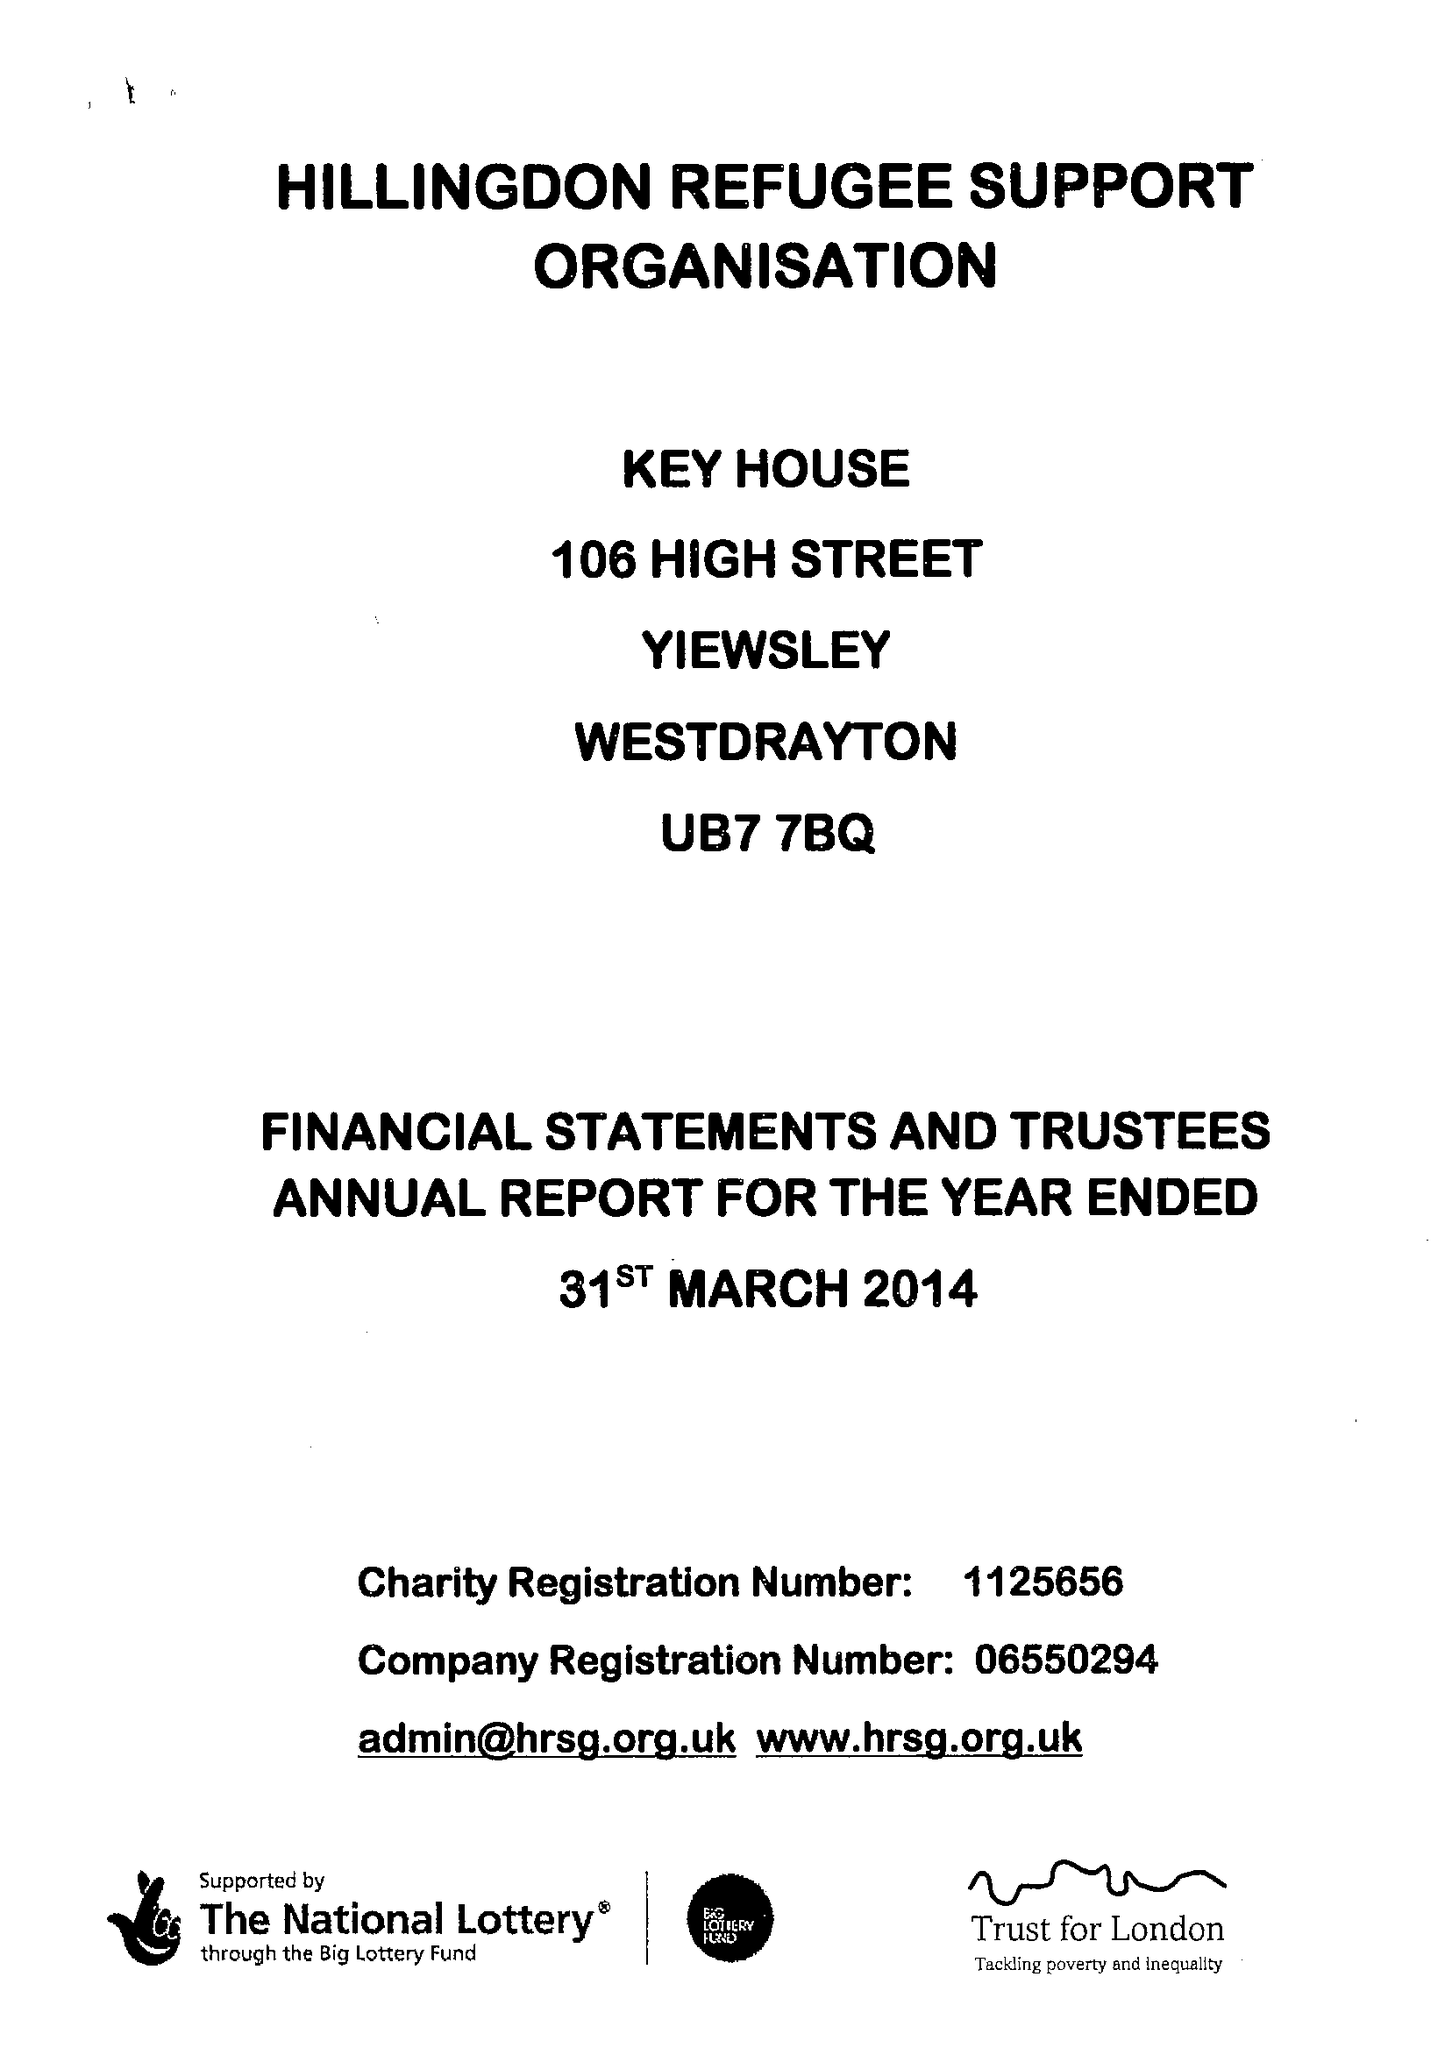What is the value for the address__postcode?
Answer the question using a single word or phrase. UB7 7BQ 